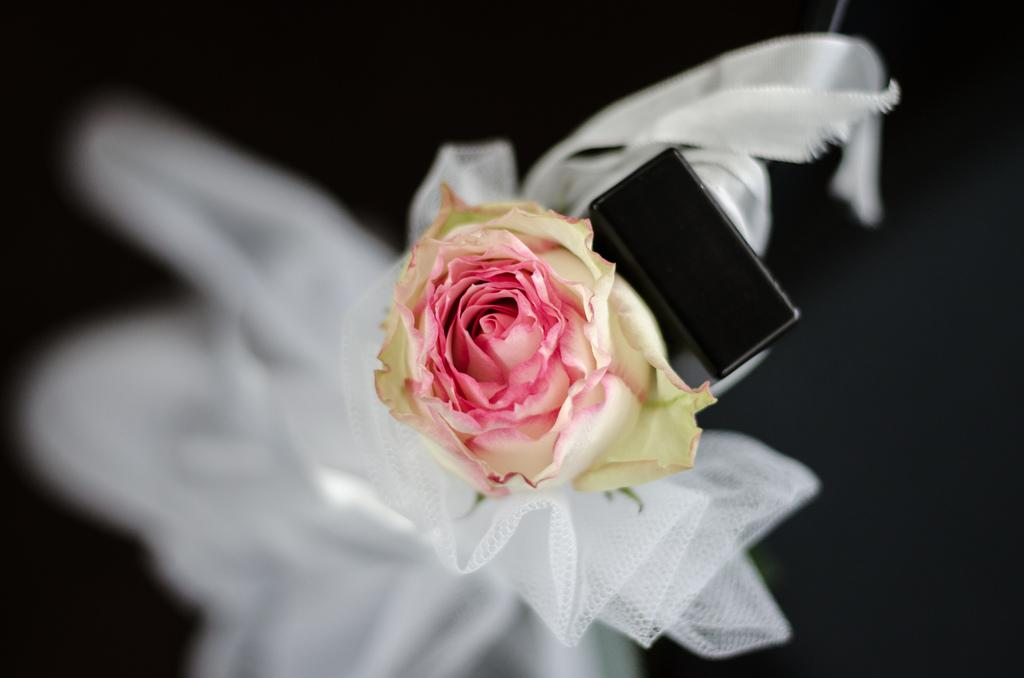What is the main subject of the image? There is a flower in the image. What else can be seen in the image besides the flower? There is a mobile and netted cloth in the image. How would you describe the background of the image? The background of the image is dark. What type of dinner is being served in the image? There is no dinner present in the image; it features a flower, a mobile, and netted cloth. What material is the mobile made of in the image? The provided facts do not mention the material of the mobile; it only states that there is a mobile in the image. 